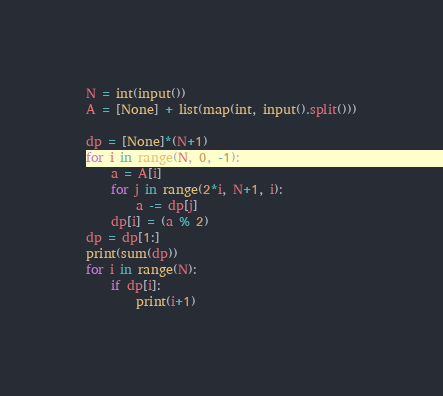<code> <loc_0><loc_0><loc_500><loc_500><_Python_>N = int(input())
A = [None] + list(map(int, input().split()))

dp = [None]*(N+1)
for i in range(N, 0, -1):
    a = A[i]
    for j in range(2*i, N+1, i):
        a -= dp[j]
    dp[i] = (a % 2)
dp = dp[1:]
print(sum(dp))
for i in range(N):
    if dp[i]:
        print(i+1)</code> 